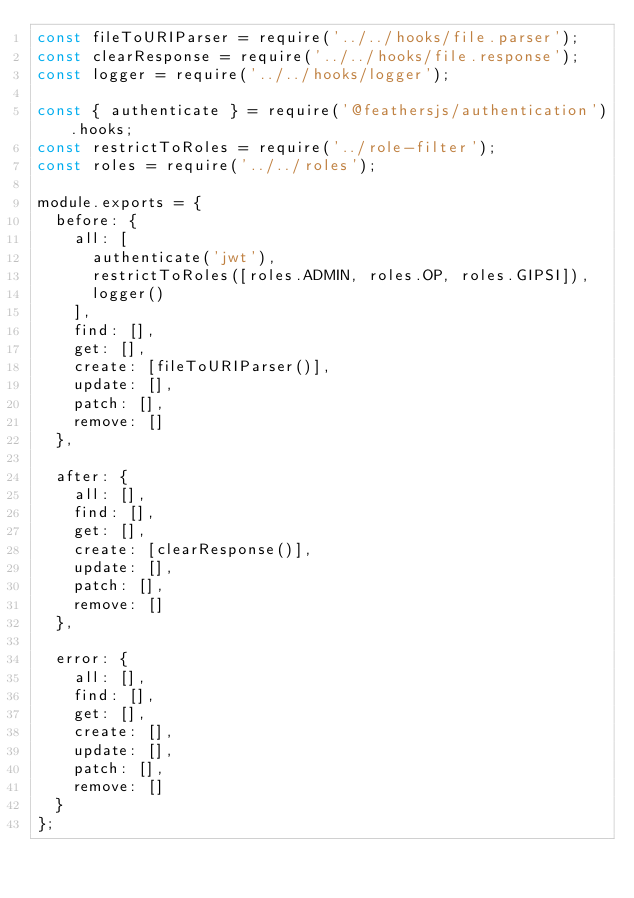Convert code to text. <code><loc_0><loc_0><loc_500><loc_500><_JavaScript_>const fileToURIParser = require('../../hooks/file.parser');
const clearResponse = require('../../hooks/file.response');
const logger = require('../../hooks/logger');

const { authenticate } = require('@feathersjs/authentication').hooks;
const restrictToRoles = require('../role-filter');
const roles = require('../../roles');

module.exports = {
	before: {
		all: [
			authenticate('jwt'),
			restrictToRoles([roles.ADMIN, roles.OP, roles.GIPSI]),
			logger()
		],
		find: [],
		get: [],
		create: [fileToURIParser()],
		update: [],
		patch: [],
		remove: []
	},

	after: {
		all: [],
		find: [],
		get: [],
		create: [clearResponse()],
		update: [],
		patch: [],
		remove: []
	},

	error: {
		all: [],
		find: [],
		get: [],
		create: [],
		update: [],
		patch: [],
		remove: []
	}
};
</code> 